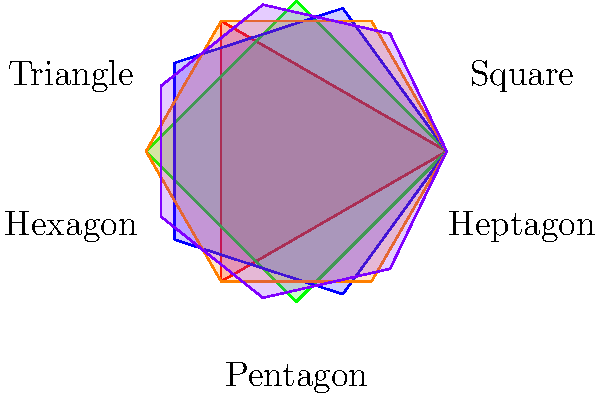As an indie game developer optimizing collision detection in your game engine, you need to determine the most efficient polygon shape for hitboxes. Given that the computational cost of collision detection is proportional to the number of vertices, and the accuracy of the hitbox improves with more vertices, which shape provides the best balance between performance and accuracy? Consider that the shapes must be convex and have a similar area for fair comparison. To determine the most efficient polygon shape for collision detection, we need to consider both performance and accuracy:

1. Performance: Fewer vertices mean faster collision detection calculations.
2. Accuracy: More vertices provide a closer approximation to the actual object shape.

Let's analyze the options:

1. Triangle (3 vertices):
   - Fastest to compute
   - Least accurate representation

2. Square (4 vertices):
   - Very fast to compute
   - Improved accuracy over triangle

3. Pentagon (5 vertices):
   - Moderately fast computation
   - Better accuracy than square

4. Hexagon (6 vertices):
   - Slightly slower computation
   - Good balance of accuracy and performance

5. Heptagon (7 vertices):
   - Slower computation
   - High accuracy, but diminishing returns compared to hexagon

The hexagon provides the best balance between performance and accuracy for several reasons:

1. It offers a good approximation of circular objects, which are common in many games.
2. The computational cost is still relatively low with only 6 vertices.
3. The accuracy improvement from hexagon to heptagon is less significant than from pentagon to hexagon.
4. In XML asset management, describing a hexagon is not significantly more complex than a pentagon.

The formula for the area of a regular polygon with $n$ sides and radius $r$ is:

$$ A = \frac{1}{2}nr^2\sin\left(\frac{2\pi}{n}\right) $$

As $n$ increases, the area approaches that of a circle ($\pi r^2$). The hexagon provides a good approximation without excessive computational cost.
Answer: Hexagon 